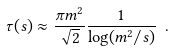<formula> <loc_0><loc_0><loc_500><loc_500>\tau ( s ) \approx \frac { \pi m ^ { 2 } } { \sqrt { 2 } } \frac { 1 } { \log ( m ^ { 2 } / s ) } \ .</formula> 